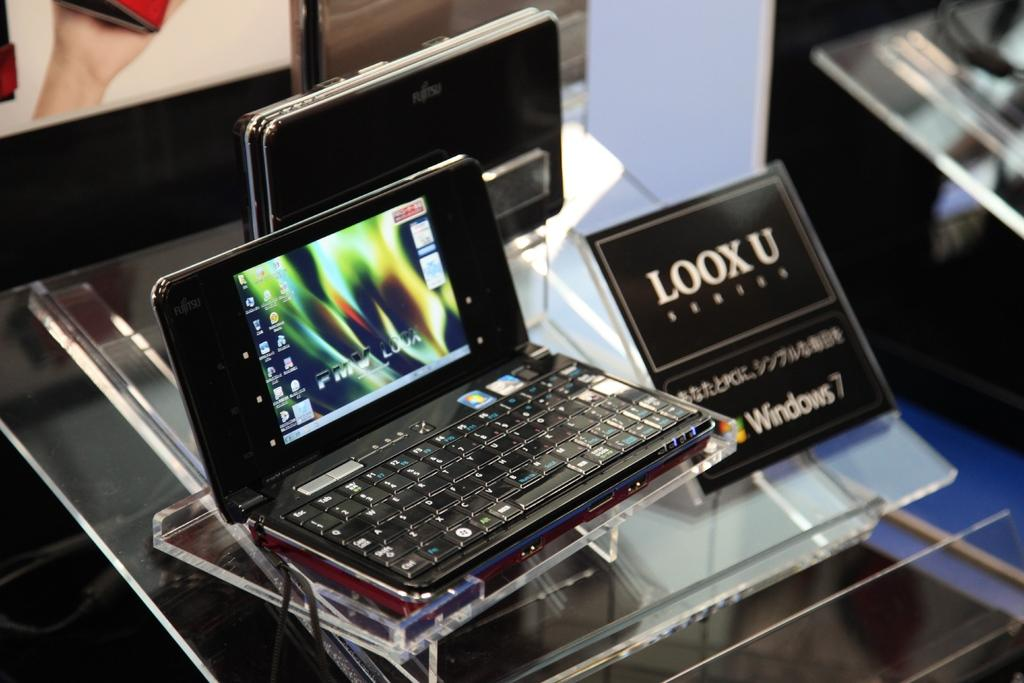<image>
Relay a brief, clear account of the picture shown. A small device by LOOX U sits on a clear stand. 